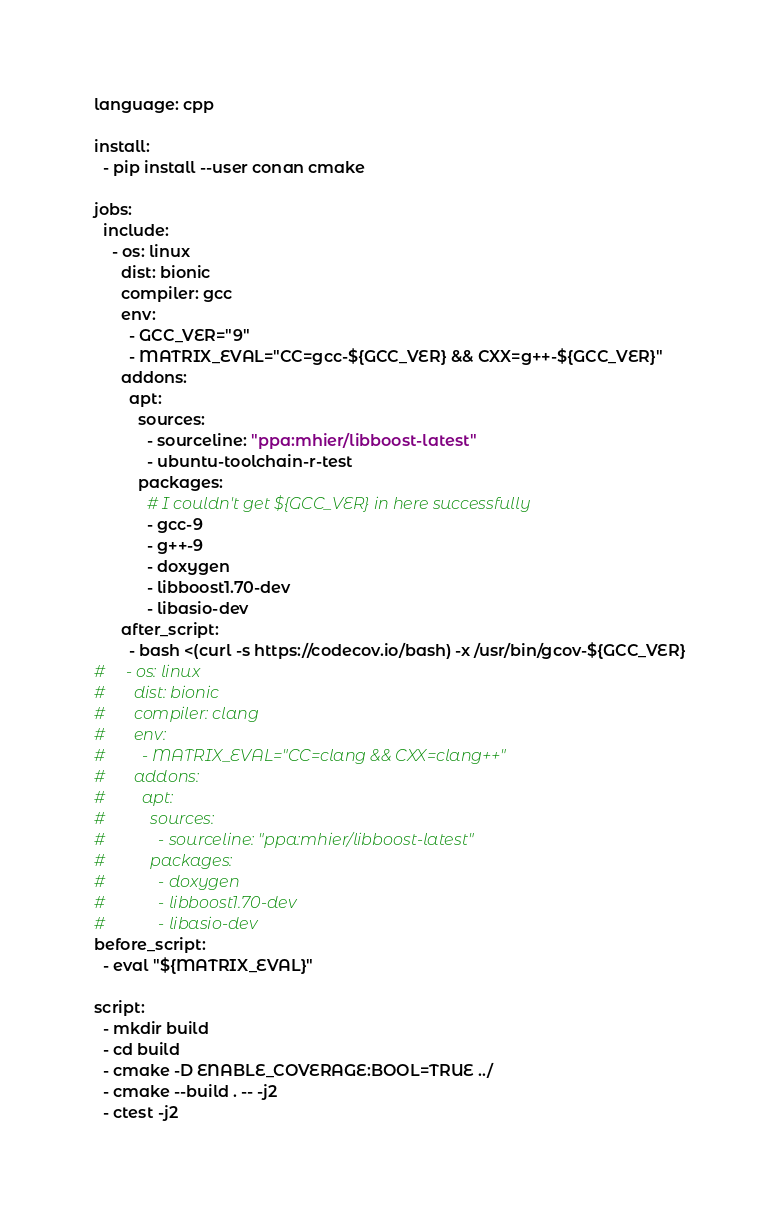Convert code to text. <code><loc_0><loc_0><loc_500><loc_500><_YAML_>language: cpp

install:
  - pip install --user conan cmake

jobs:
  include:
    - os: linux
      dist: bionic
      compiler: gcc
      env:
        - GCC_VER="9"
        - MATRIX_EVAL="CC=gcc-${GCC_VER} && CXX=g++-${GCC_VER}"
      addons:
        apt:
          sources:
            - sourceline: "ppa:mhier/libboost-latest"
            - ubuntu-toolchain-r-test
          packages:
            # I couldn't get ${GCC_VER} in here successfully
            - gcc-9
            - g++-9
            - doxygen
            - libboost1.70-dev
            - libasio-dev
      after_script:
        - bash <(curl -s https://codecov.io/bash) -x /usr/bin/gcov-${GCC_VER}
#     - os: linux
#       dist: bionic
#       compiler: clang
#       env:
#         - MATRIX_EVAL="CC=clang && CXX=clang++"
#       addons:
#         apt:
#           sources:
#             - sourceline: "ppa:mhier/libboost-latest"
#           packages:
#             - doxygen
#             - libboost1.70-dev
#             - libasio-dev
before_script:
  - eval "${MATRIX_EVAL}"

script:
  - mkdir build
  - cd build
  - cmake -D ENABLE_COVERAGE:BOOL=TRUE ../
  - cmake --build . -- -j2
  - ctest -j2
</code> 